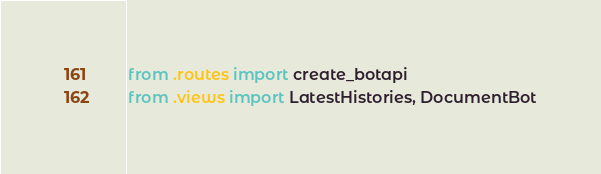<code> <loc_0><loc_0><loc_500><loc_500><_Python_>from .routes import create_botapi
from .views import LatestHistories, DocumentBot
</code> 